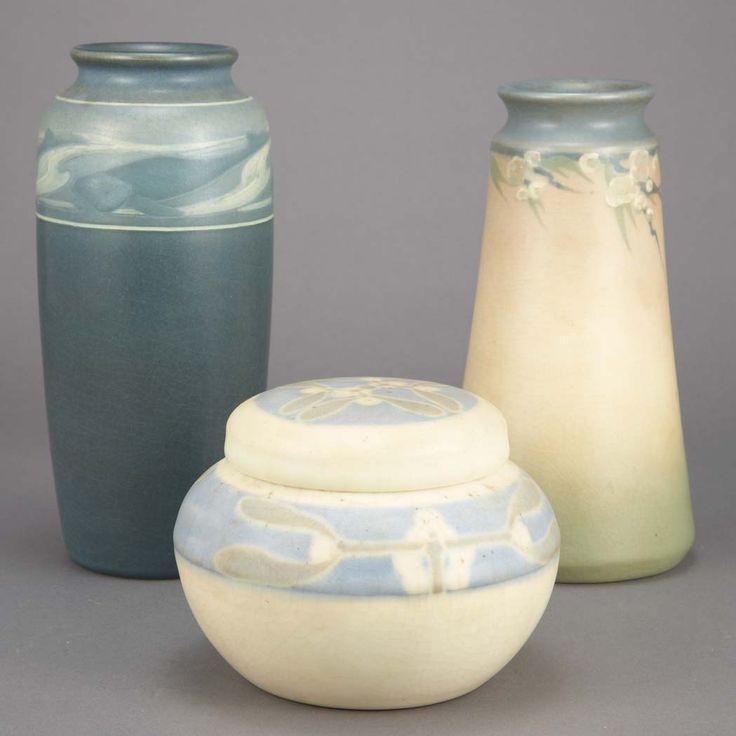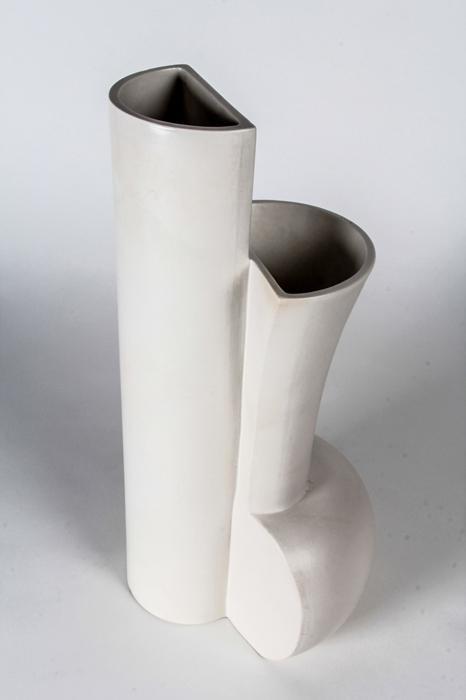The first image is the image on the left, the second image is the image on the right. For the images shown, is this caption "One image shows two vases that are similar in size with top openings that are smaller than the body of the vase, but that are different designs." true? Answer yes or no. No. 